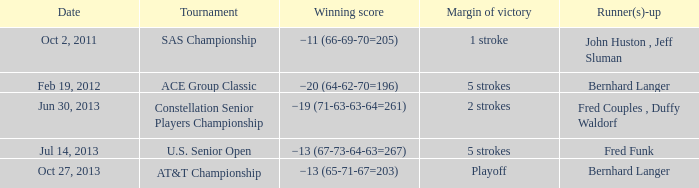Which Date has a Margin of victory of 5 strokes, and a Winning score of −13 (67-73-64-63=267)? Jul 14, 2013. 